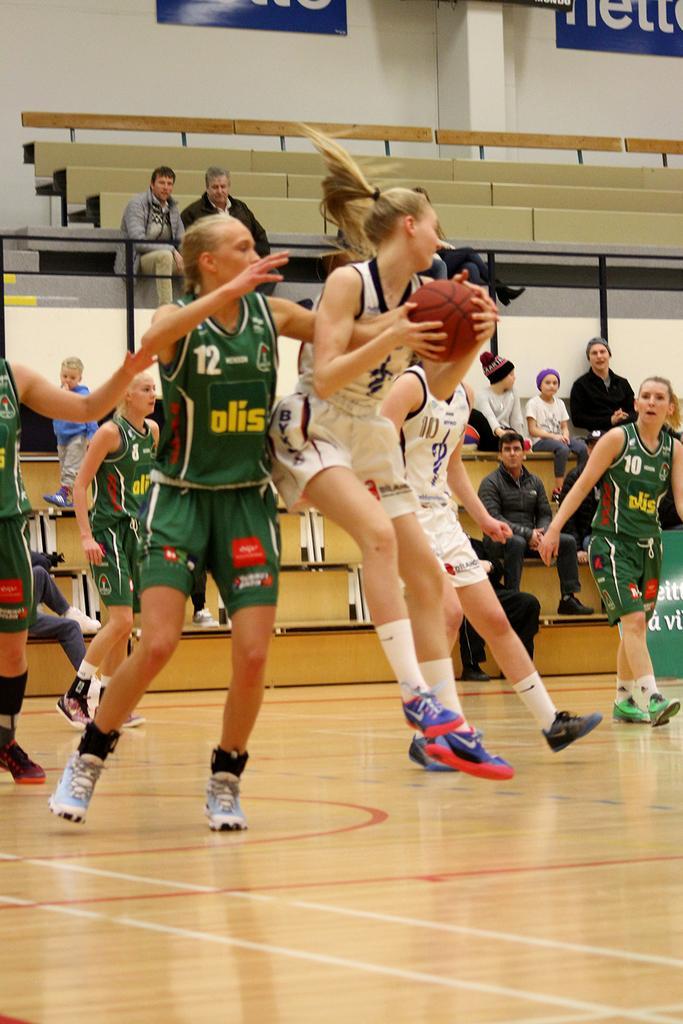Can you describe this image briefly? In the center of the image we can see some persons, a lady is holding a ball are there. In the background of the image some persons are sitting and we can see stairs, wall, boards are there. At the bottom of the image floor is there. 